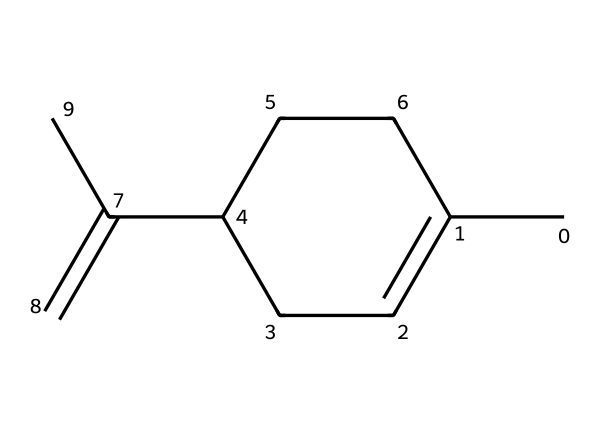What is the molecular formula of limonene? The molecular formula can be determined by counting the number of carbon and hydrogen atoms in the structure. There are 10 carbon atoms (C) and 16 hydrogen atoms (H), resulting in the formula C10H16.
Answer: C10H16 How many double bonds are present in limonene? The structure shows one double bond between two carbon atoms, which can be identified as part of the C=C connections in the chemical structure.
Answer: 1 What is the primary functional group in limonene? The structure of limonene features a carbon-carbon double bond (alkene), which is the primary functional group, indicating the compound is an alkene.
Answer: alkene Which type of terpene is limonene classified as? Limonene is classified as a monoterpene because it consists of 10 carbon atoms, which is characteristic of monoterpenes.
Answer: monoterpene What is the common use of limonene in household products? Limonene is commonly used for its pleasant citrus aroma in cleaning products and air fresheners, providing both scent and degreasing properties.
Answer: cleaning products How does the cyclic structure of limonene influence its properties? The cyclic structure contributes to the stability and volatility of limonene, making it effective as a fragrance and solvent, as cyclic compounds often have distinct aromatic properties.
Answer: stability and volatility 